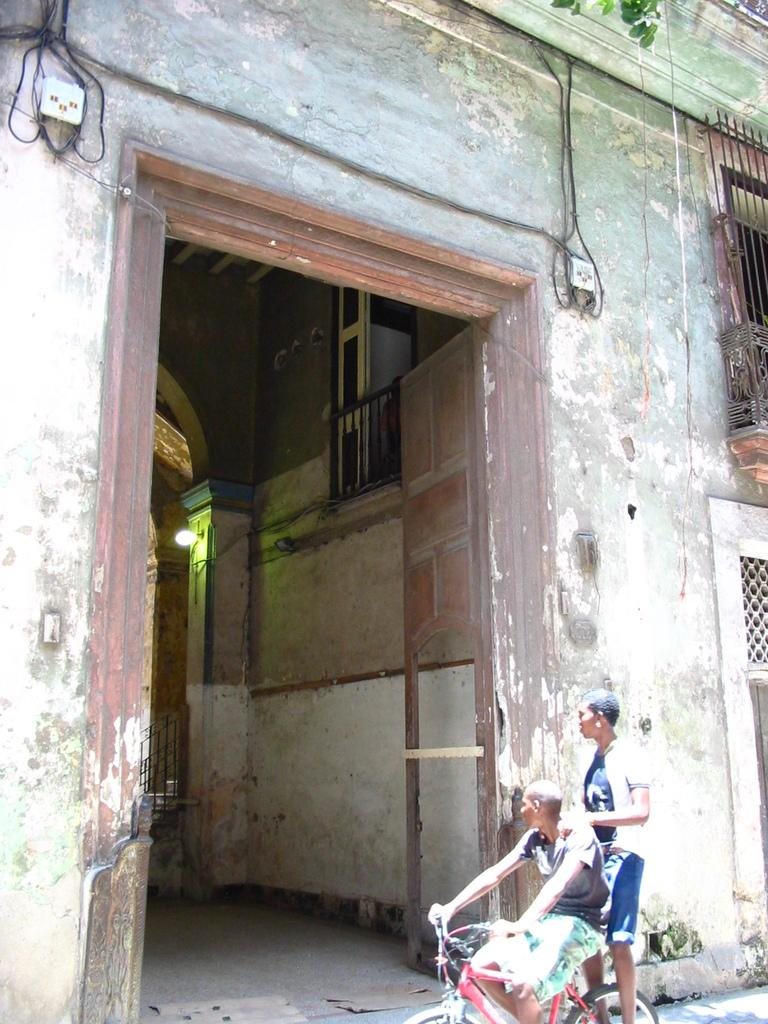Where was the image taken? The image was taken outside of a house. How many people are in the image? There are two persons in the image. What are the positions of the two people? One person is standing, and another person is sitting on a bicycle. What architectural features can be seen in the background? There is a wall, a door, a window, and a socket visible in the background. What type of coat is the person wearing while riding the bicycle? There is no coat visible in the image; the person is sitting on a bicycle without any apparent outerwear. 